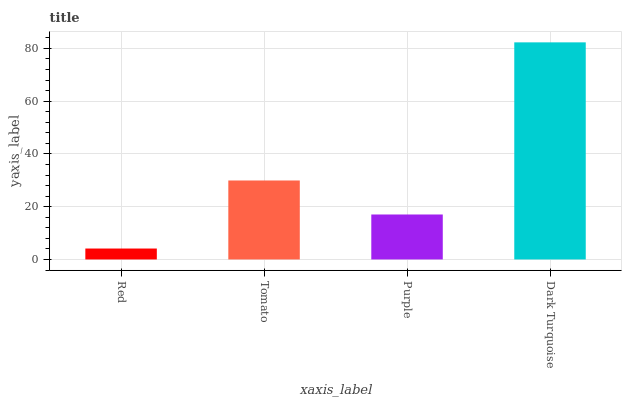Is Red the minimum?
Answer yes or no. Yes. Is Dark Turquoise the maximum?
Answer yes or no. Yes. Is Tomato the minimum?
Answer yes or no. No. Is Tomato the maximum?
Answer yes or no. No. Is Tomato greater than Red?
Answer yes or no. Yes. Is Red less than Tomato?
Answer yes or no. Yes. Is Red greater than Tomato?
Answer yes or no. No. Is Tomato less than Red?
Answer yes or no. No. Is Tomato the high median?
Answer yes or no. Yes. Is Purple the low median?
Answer yes or no. Yes. Is Red the high median?
Answer yes or no. No. Is Tomato the low median?
Answer yes or no. No. 